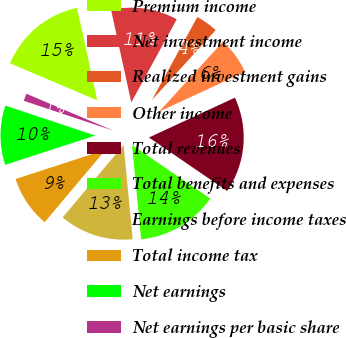Convert chart to OTSL. <chart><loc_0><loc_0><loc_500><loc_500><pie_chart><fcel>Premium income<fcel>Net investment income<fcel>Realized investment gains<fcel>Other income<fcel>Total revenues<fcel>Total benefits and expenses<fcel>Earnings before income taxes<fcel>Total income tax<fcel>Net earnings<fcel>Net earnings per basic share<nl><fcel>15.19%<fcel>11.39%<fcel>3.8%<fcel>6.33%<fcel>16.46%<fcel>13.92%<fcel>12.66%<fcel>8.86%<fcel>10.13%<fcel>1.27%<nl></chart> 